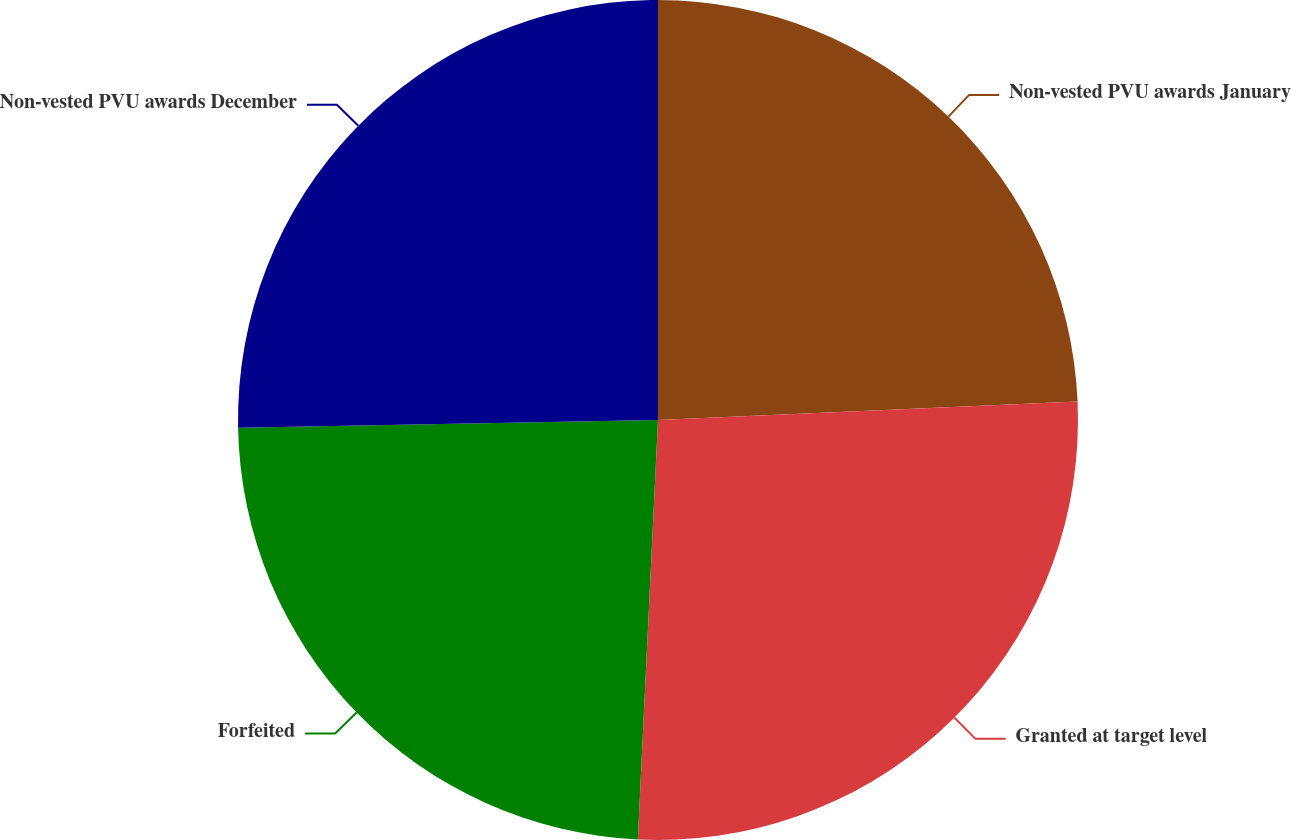Convert chart to OTSL. <chart><loc_0><loc_0><loc_500><loc_500><pie_chart><fcel>Non-vested PVU awards January<fcel>Granted at target level<fcel>Forfeited<fcel>Non-vested PVU awards December<nl><fcel>24.3%<fcel>26.46%<fcel>23.94%<fcel>25.29%<nl></chart> 